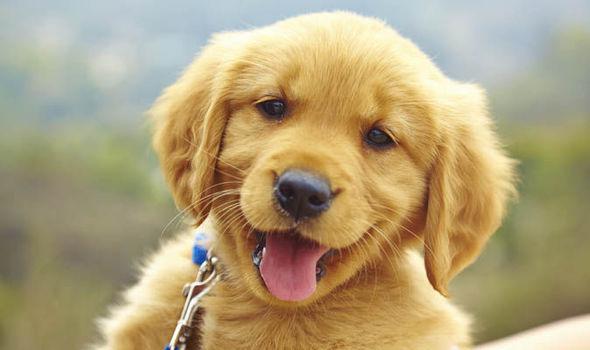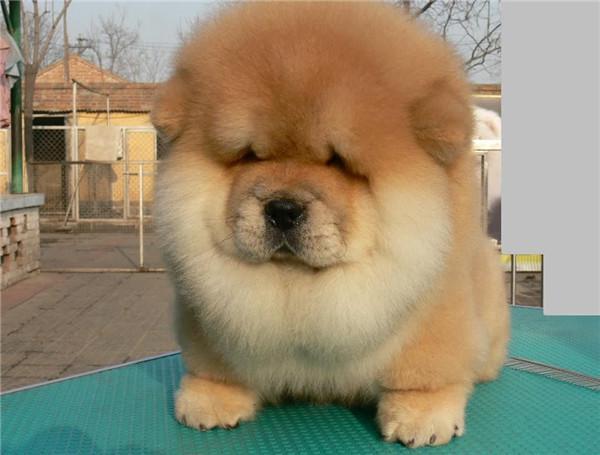The first image is the image on the left, the second image is the image on the right. Given the left and right images, does the statement "A chow dog is shown standing on brick." hold true? Answer yes or no. No. 